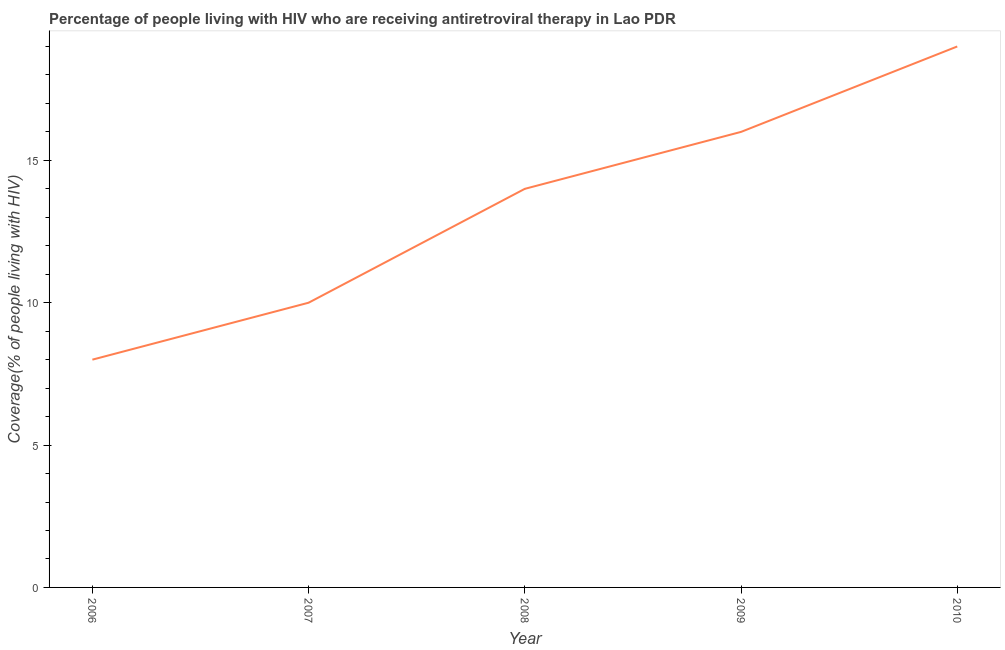What is the antiretroviral therapy coverage in 2010?
Make the answer very short. 19. Across all years, what is the maximum antiretroviral therapy coverage?
Provide a succinct answer. 19. Across all years, what is the minimum antiretroviral therapy coverage?
Your answer should be compact. 8. In which year was the antiretroviral therapy coverage minimum?
Your answer should be very brief. 2006. What is the sum of the antiretroviral therapy coverage?
Provide a succinct answer. 67. What is the difference between the antiretroviral therapy coverage in 2006 and 2009?
Make the answer very short. -8. What is the average antiretroviral therapy coverage per year?
Provide a short and direct response. 13.4. In how many years, is the antiretroviral therapy coverage greater than 5 %?
Your answer should be compact. 5. What is the ratio of the antiretroviral therapy coverage in 2006 to that in 2009?
Ensure brevity in your answer.  0.5. Is the difference between the antiretroviral therapy coverage in 2007 and 2009 greater than the difference between any two years?
Your response must be concise. No. What is the difference between the highest and the lowest antiretroviral therapy coverage?
Make the answer very short. 11. Does the antiretroviral therapy coverage monotonically increase over the years?
Provide a succinct answer. Yes. How many lines are there?
Provide a succinct answer. 1. How many years are there in the graph?
Offer a terse response. 5. What is the difference between two consecutive major ticks on the Y-axis?
Provide a succinct answer. 5. Does the graph contain any zero values?
Your response must be concise. No. What is the title of the graph?
Keep it short and to the point. Percentage of people living with HIV who are receiving antiretroviral therapy in Lao PDR. What is the label or title of the Y-axis?
Your answer should be very brief. Coverage(% of people living with HIV). What is the Coverage(% of people living with HIV) in 2006?
Your answer should be very brief. 8. What is the Coverage(% of people living with HIV) of 2007?
Your answer should be compact. 10. What is the Coverage(% of people living with HIV) of 2009?
Give a very brief answer. 16. What is the Coverage(% of people living with HIV) of 2010?
Your answer should be very brief. 19. What is the difference between the Coverage(% of people living with HIV) in 2006 and 2010?
Give a very brief answer. -11. What is the difference between the Coverage(% of people living with HIV) in 2007 and 2009?
Offer a terse response. -6. What is the ratio of the Coverage(% of people living with HIV) in 2006 to that in 2008?
Provide a succinct answer. 0.57. What is the ratio of the Coverage(% of people living with HIV) in 2006 to that in 2010?
Offer a terse response. 0.42. What is the ratio of the Coverage(% of people living with HIV) in 2007 to that in 2008?
Provide a succinct answer. 0.71. What is the ratio of the Coverage(% of people living with HIV) in 2007 to that in 2009?
Your answer should be compact. 0.62. What is the ratio of the Coverage(% of people living with HIV) in 2007 to that in 2010?
Your answer should be compact. 0.53. What is the ratio of the Coverage(% of people living with HIV) in 2008 to that in 2009?
Provide a short and direct response. 0.88. What is the ratio of the Coverage(% of people living with HIV) in 2008 to that in 2010?
Give a very brief answer. 0.74. What is the ratio of the Coverage(% of people living with HIV) in 2009 to that in 2010?
Your answer should be compact. 0.84. 